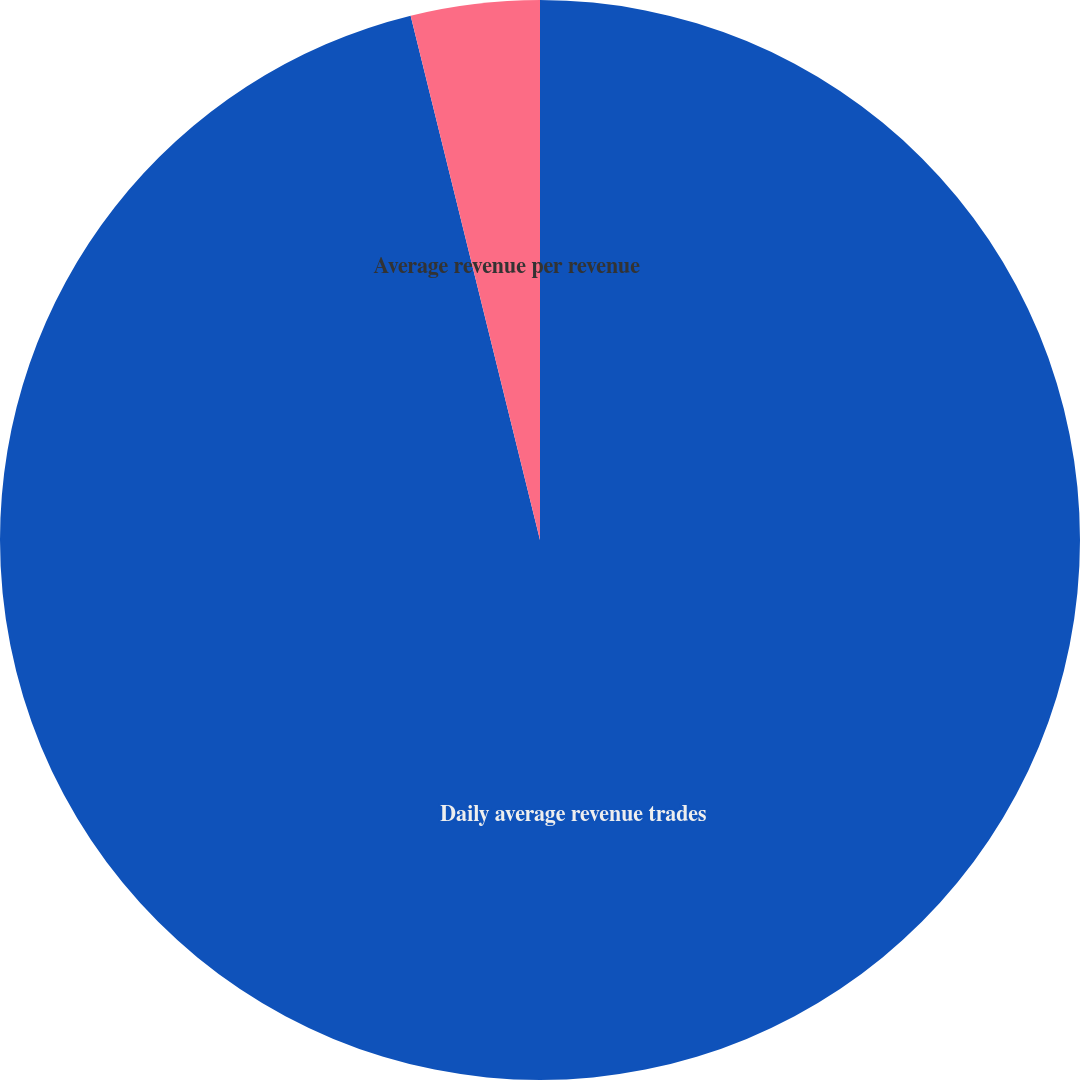Convert chart to OTSL. <chart><loc_0><loc_0><loc_500><loc_500><pie_chart><fcel>Daily average revenue trades<fcel>Average revenue per revenue<nl><fcel>96.15%<fcel>3.85%<nl></chart> 